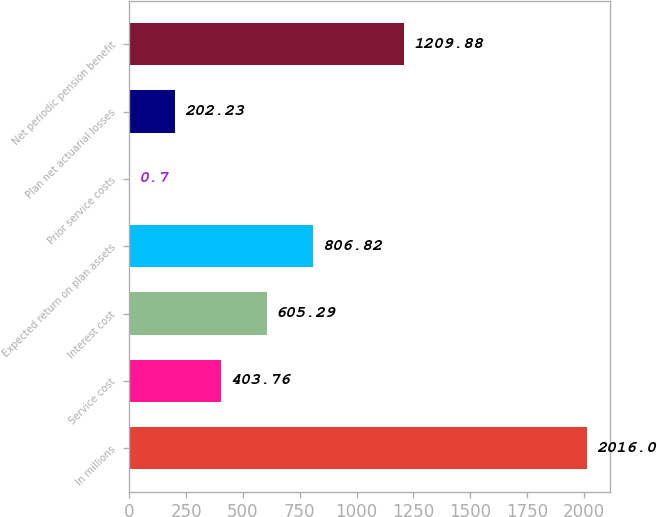Convert chart to OTSL. <chart><loc_0><loc_0><loc_500><loc_500><bar_chart><fcel>In millions<fcel>Service cost<fcel>Interest cost<fcel>Expected return on plan assets<fcel>Prior service costs<fcel>Plan net actuarial losses<fcel>Net periodic pension benefit<nl><fcel>2016<fcel>403.76<fcel>605.29<fcel>806.82<fcel>0.7<fcel>202.23<fcel>1209.88<nl></chart> 